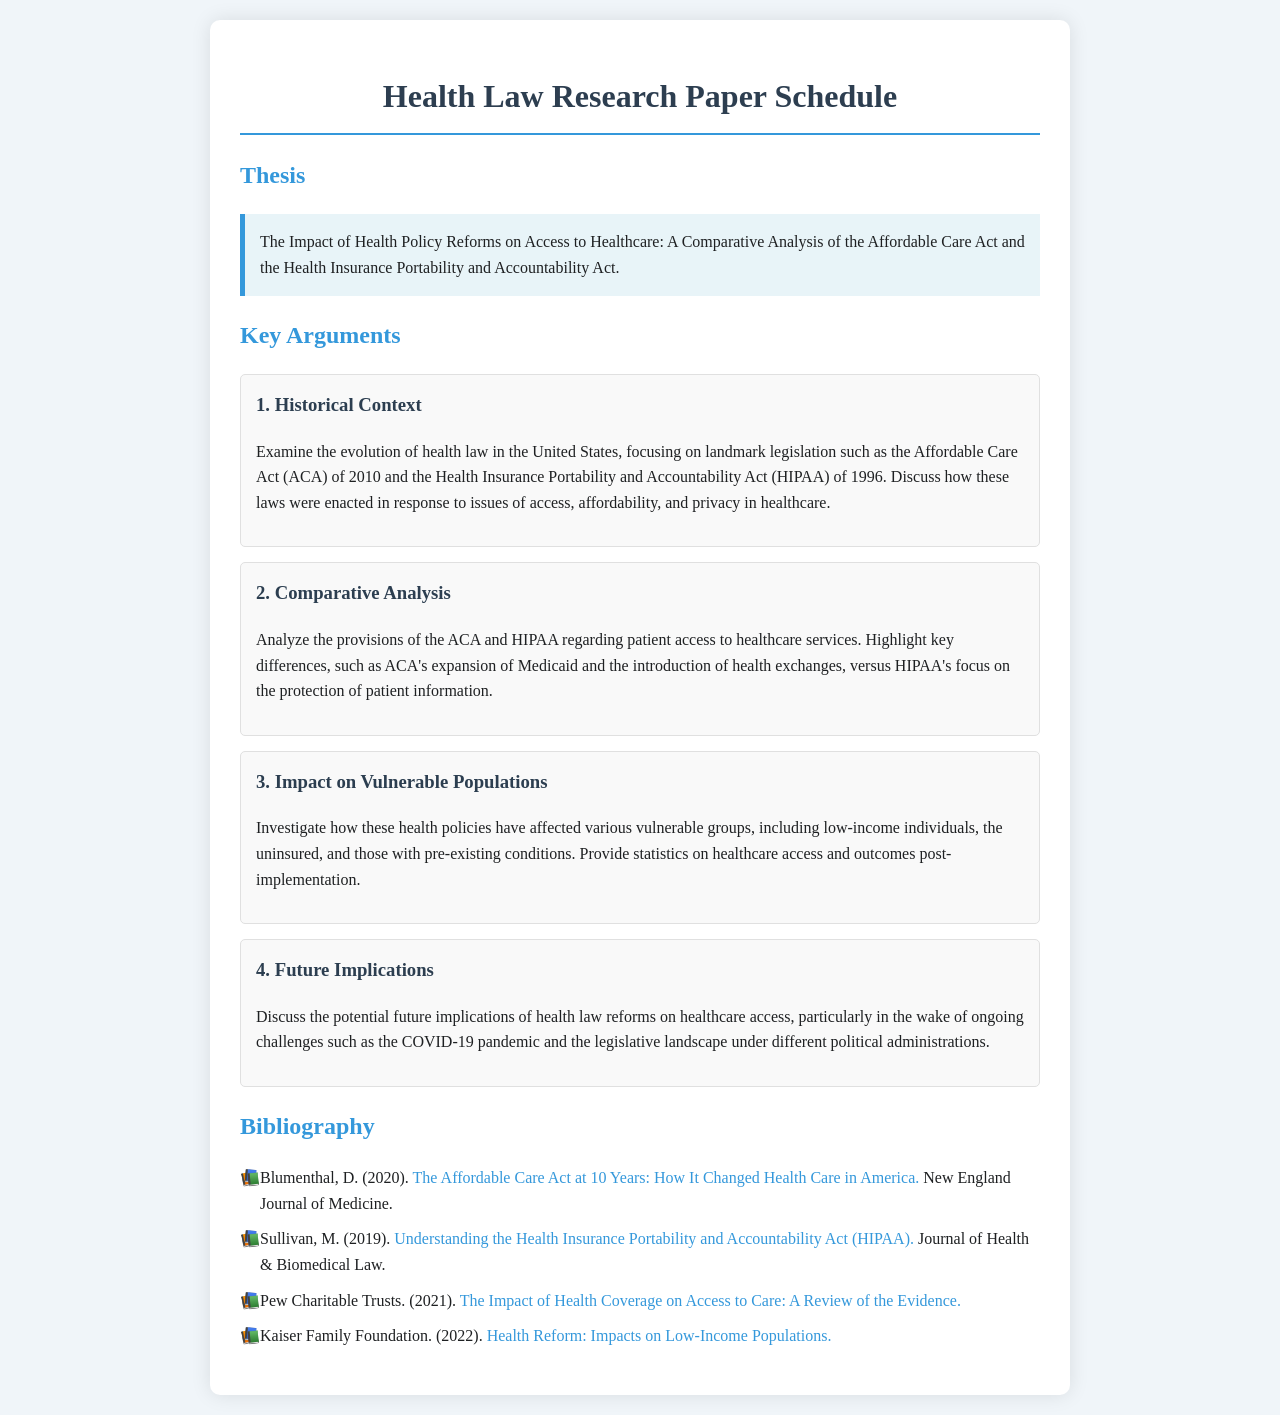What is the thesis of the research paper? The thesis statement provides the central argument of the paper, focusing on health policy reforms and their impact on access to healthcare.
Answer: The Impact of Health Policy Reforms on Access to Healthcare: A Comparative Analysis of the Affordable Care Act and the Health Insurance Portability and Accountability Act How many key arguments are presented in the document? The document enumerates the key arguments that support the thesis, allowing for a clear understanding of the main points of discussion.
Answer: 4 What is the first key argument? The first key argument is presented to provide a foundation for the discussion on health law evolution in the U.S.
Answer: Historical Context Which act expanded Medicaid? The document mentions provisions related to Medicaid expansion within one of the key arguments, highlighting its significance in healthcare access.
Answer: Affordable Care Act What does the third argument investigate? The third argument focuses on the effects of health policies on specific demographics, addressing disparities in access.
Answer: Impact on Vulnerable Populations What organization published a report on the impact of health coverage on access to care? The bibliography cites organizations and authors that provide insights into health law and policy.
Answer: Pew Charitable Trusts How many sources are listed in the bibliography? The number of sources in the bibliography indicates the extent of research conducted to support the paper's arguments.
Answer: 4 What is the focus of the second key argument? The reasoning for the second argument involves a comparative overview of specific provisions in the health laws being analyzed.
Answer: Comparative Analysis What year was the Affordable Care Act enacted? Understanding the timeline of important legislation is crucial for contextualizing its impact on health law.
Answer: 2010 